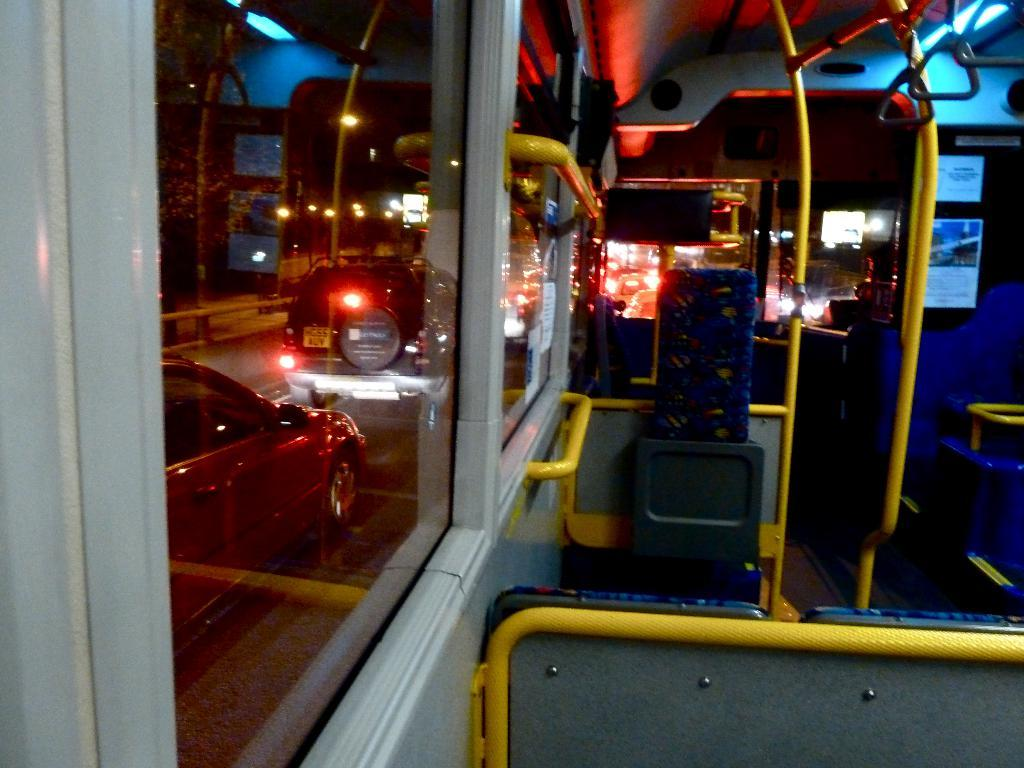What type of space is depicted in the image? The image shows the inner view of a motor vehicle. What can be found inside the motor vehicle? There are seats inside the motor vehicle. Are there any structural elements visible in the motor vehicle? Yes, there are iron rods visible in the motor vehicle. What can be seen in the background of the image? In the background, there are motor vehicles on the road. What type of beginner's course is being taught in the motor vehicle? There is no indication in the image that a beginner's course is being taught in the motor vehicle. 